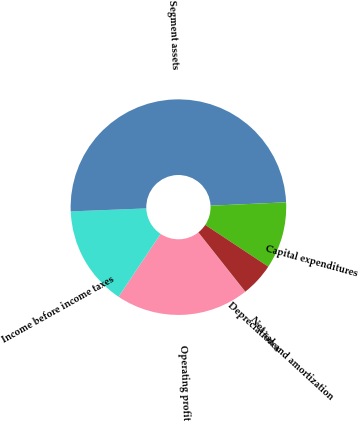Convert chart to OTSL. <chart><loc_0><loc_0><loc_500><loc_500><pie_chart><fcel>Net sales<fcel>Operating profit<fcel>Income before income taxes<fcel>Segment assets<fcel>Capital expenditures<fcel>Depreciation and amortization<nl><fcel>0.04%<fcel>19.99%<fcel>15.0%<fcel>49.91%<fcel>10.02%<fcel>5.03%<nl></chart> 